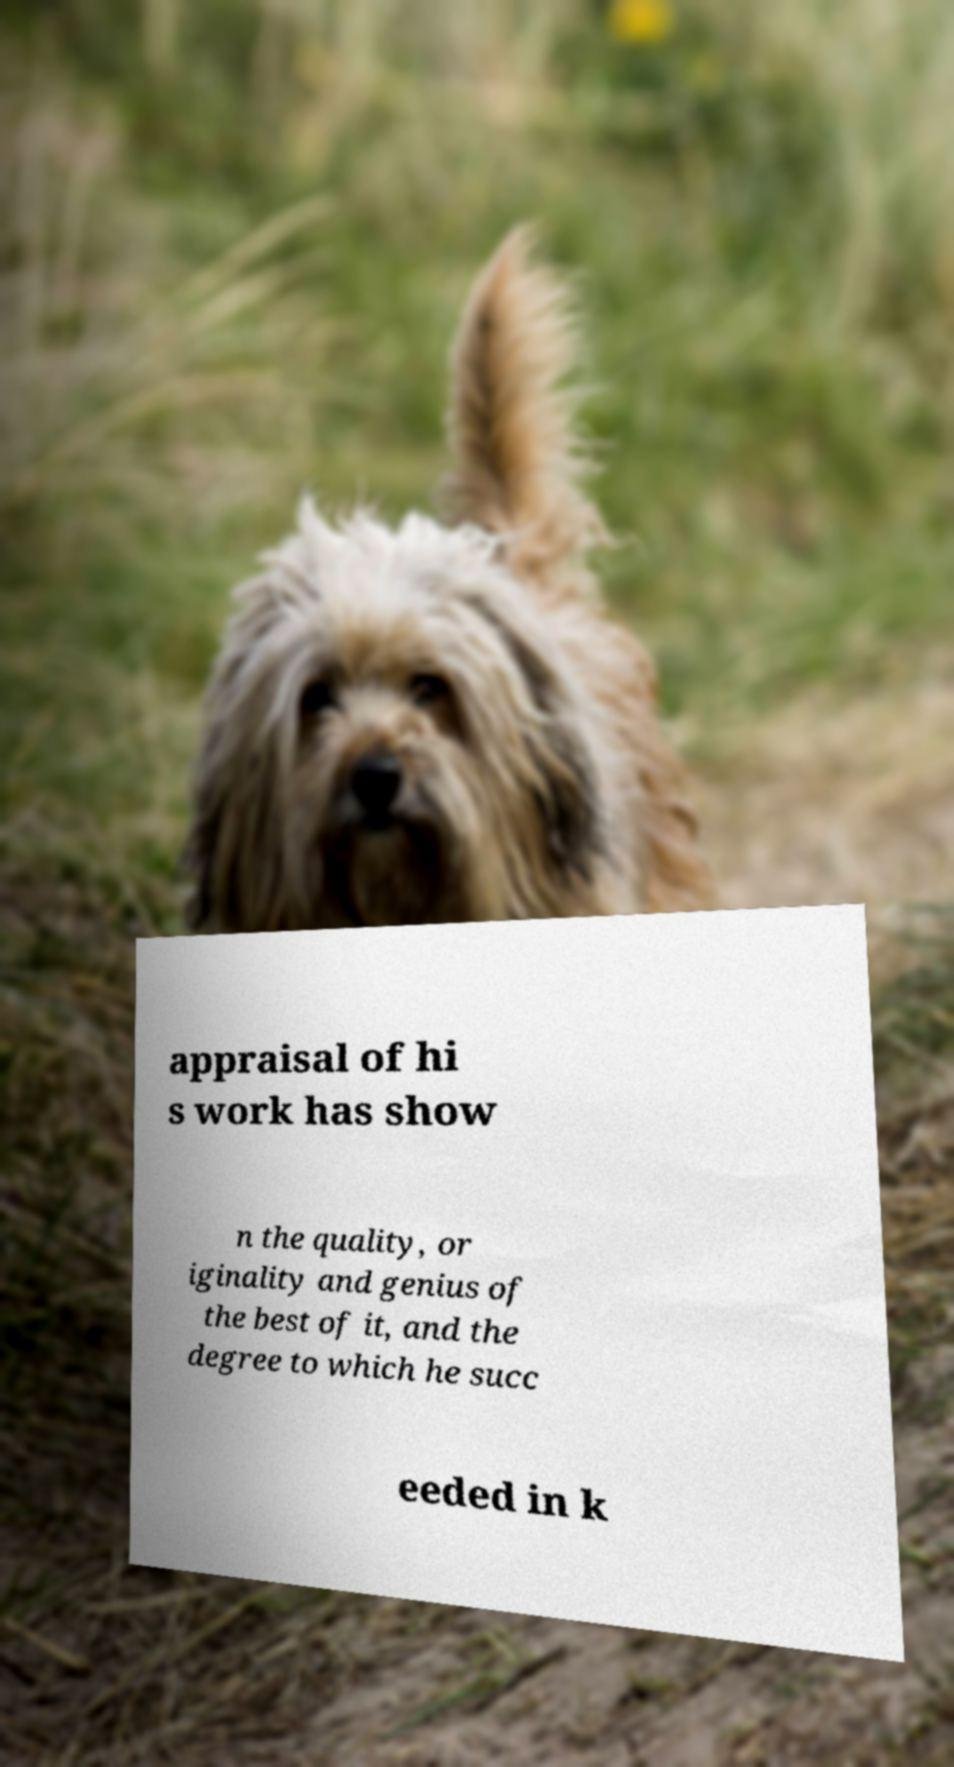Could you assist in decoding the text presented in this image and type it out clearly? appraisal of hi s work has show n the quality, or iginality and genius of the best of it, and the degree to which he succ eeded in k 